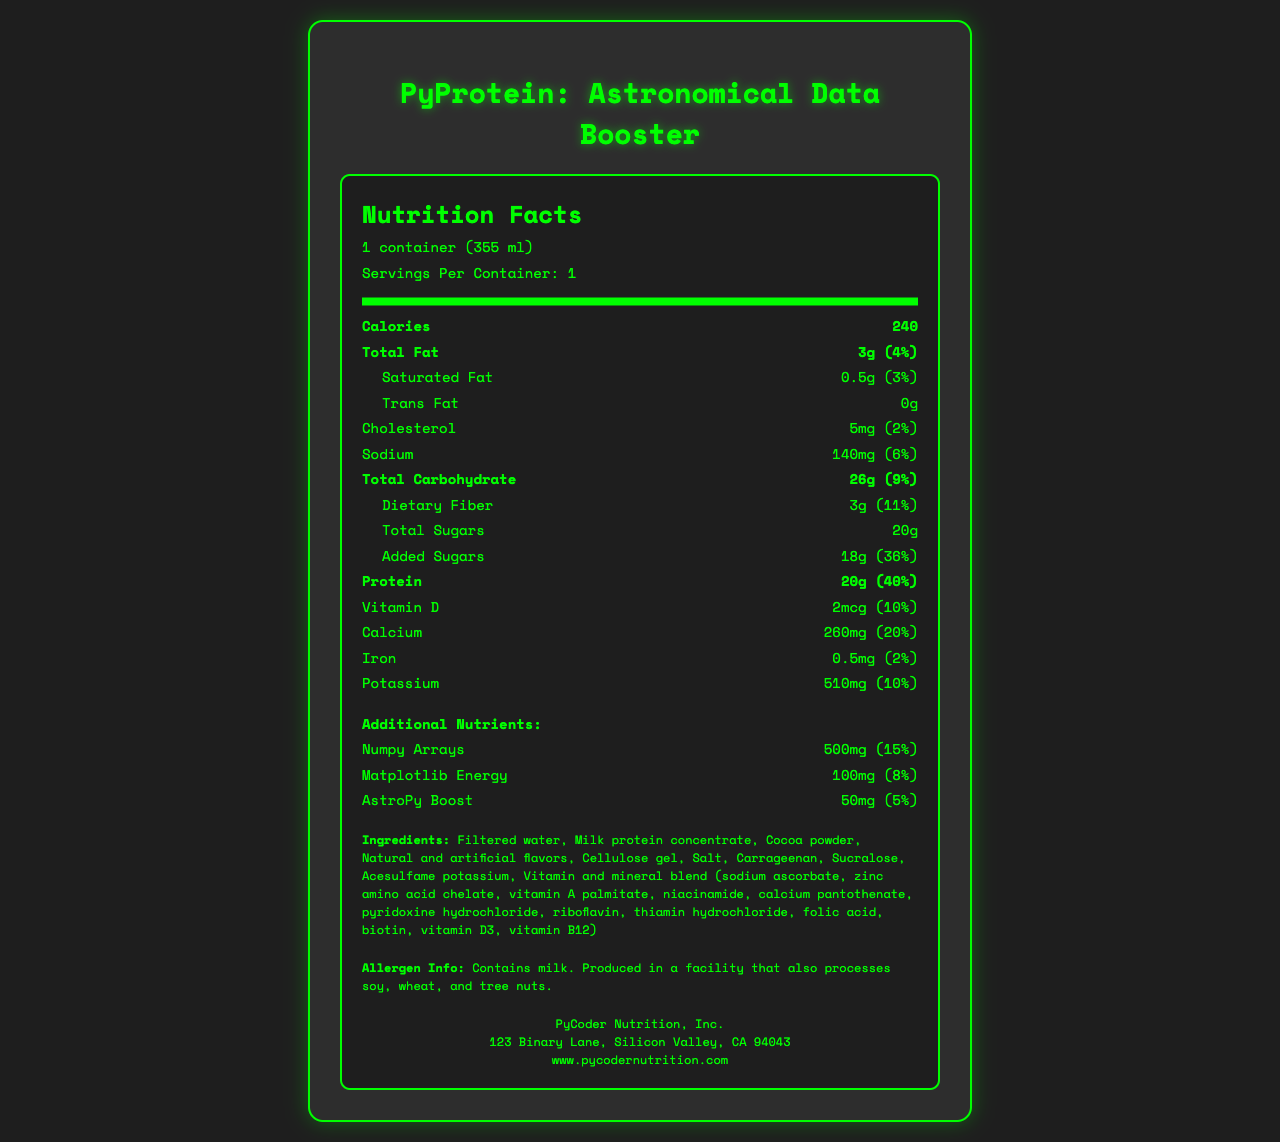what is the serving size? The serving size is clearly mentioned at the beginning of the document under "Nutrition Facts".
Answer: 1 container (355 ml) how many calories are in one serving of the shake? The number of calories is listed right after the serving size and servings per container.
Answer: 240 what percentage of the daily value of protein does one serving provide? The daily value percentage for protein can be found next to the amount (20g).
Answer: 40% how much sodium does one serving contain? The amount of sodium in one serving is listed along with the daily value percentage (6%).
Answer: 140 mg list three ingredients found in the PyProtein shake The ingredients are listed towards the bottom of the document.
Answer: Filtered water, Milk protein concentrate, Cocoa powder which additional nutrient has the highest daily value percentage? A. Numpy Arrays B. Matplotlib Energy C. AstroPy Boost Numpy Arrays have a daily value percentage of 15%, which is higher than both Matplotlib Energy (8%) and AstroPy Boost (5%).
Answer: A. Numpy Arrays what is the total carbohydrate content in the shake? A. 20g B. 26g C. 10g D. 30g The total carbohydrate content is 26g, as mentioned under the bolded "Total Carbohydrate" section.
Answer: B. 26g is there any trans fat in the shake? The amount of trans fat is listed as 0g.
Answer: No briefly describe the main details included in the document. The document is a comprehensive nutrition label for the shake, highlighting its contents and providing necessary detail for consumers.
Answer: The document provides detailed nutrition facts for the 'PyProtein: Astronomical Data Booster' shake, including information on calories, total fat, cholesterol, sodium, carbohydrates, sugars, protein, vitamins, and minerals. Additional nutrients specific to the Python programming theme are also listed. Ingredients, allergen information, and manufacturer details are included as well. how is the protein content in the shake primarily sourced? The document lists "Milk protein concentrate" as an ingredient, but it does not specify if this is the only source of protein. Thus, the exact source of all protein content cannot be determined.
Answer: Cannot be determined 